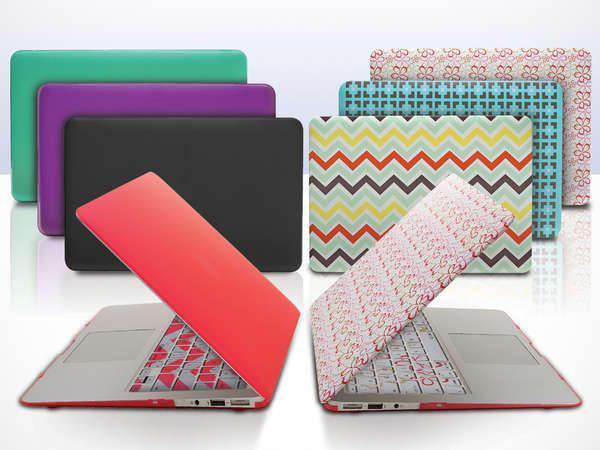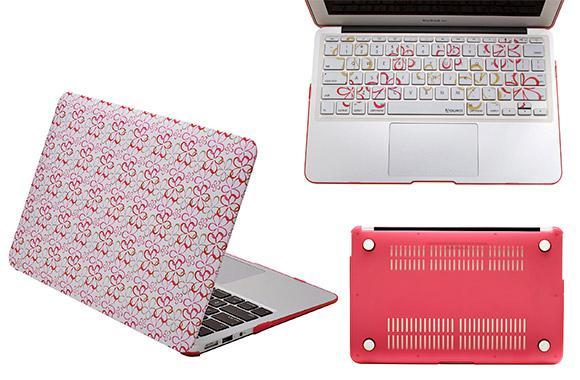The first image is the image on the left, the second image is the image on the right. Evaluate the accuracy of this statement regarding the images: "A person's hand is near a digital device.". Is it true? Answer yes or no. No. The first image is the image on the left, the second image is the image on the right. Considering the images on both sides, is "An image shows an open red device and a device with a patterned cover posed back-to-back in front of rows of closed devices." valid? Answer yes or no. Yes. 